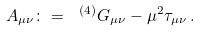<formula> <loc_0><loc_0><loc_500><loc_500>A _ { \mu \nu } \colon = \ ^ { ( 4 ) } G _ { \mu \nu } - \mu ^ { 2 } \tau _ { \mu \nu } \, .</formula> 